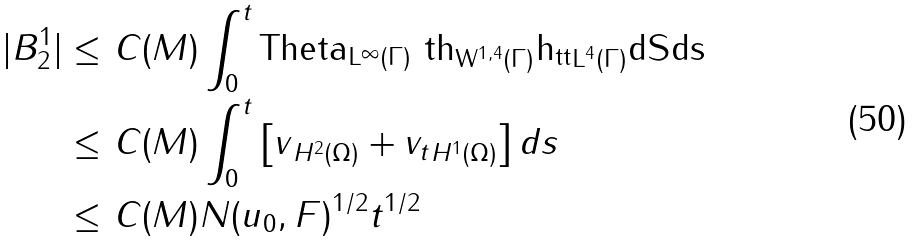<formula> <loc_0><loc_0><loc_500><loc_500>| B _ { 2 } ^ { 1 } | \leq & \ C ( M ) \int _ { 0 } ^ { t } \| \tt T h e t a \| _ { L ^ { \infty } ( \Gamma ) } \| \ t h \| _ { W ^ { 1 , 4 } ( \Gamma ) } \| h _ { t t } \| _ { L ^ { 4 } ( \Gamma ) } d S d s \\ \leq & \ C ( M ) \int _ { 0 } ^ { t } \left [ \| v \| _ { H ^ { 2 } ( \Omega ) } + \| v _ { t } \| _ { H ^ { 1 } ( \Omega ) } \right ] d s \\ \leq & \ C ( M ) N ( u _ { 0 } , F ) ^ { 1 / 2 } t ^ { 1 / 2 }</formula> 